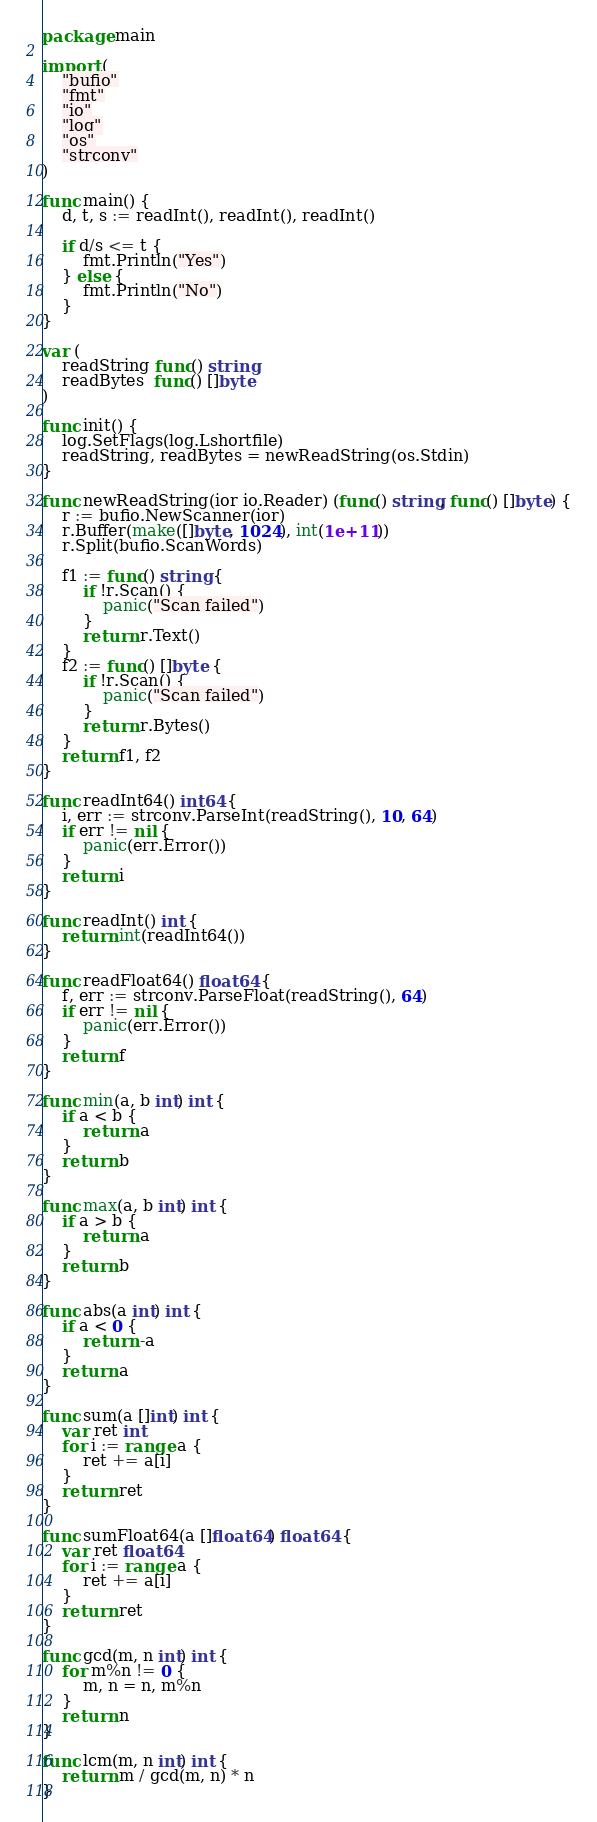Convert code to text. <code><loc_0><loc_0><loc_500><loc_500><_Go_>package main

import (
	"bufio"
	"fmt"
	"io"
	"log"
	"os"
	"strconv"
)

func main() {
	d, t, s := readInt(), readInt(), readInt()

	if d/s <= t {
		fmt.Println("Yes")
	} else {
		fmt.Println("No")
	}
}

var (
	readString func() string
	readBytes  func() []byte
)

func init() {
	log.SetFlags(log.Lshortfile)
	readString, readBytes = newReadString(os.Stdin)
}

func newReadString(ior io.Reader) (func() string, func() []byte) {
	r := bufio.NewScanner(ior)
	r.Buffer(make([]byte, 1024), int(1e+11))
	r.Split(bufio.ScanWords)

	f1 := func() string {
		if !r.Scan() {
			panic("Scan failed")
		}
		return r.Text()
	}
	f2 := func() []byte {
		if !r.Scan() {
			panic("Scan failed")
		}
		return r.Bytes()
	}
	return f1, f2
}

func readInt64() int64 {
	i, err := strconv.ParseInt(readString(), 10, 64)
	if err != nil {
		panic(err.Error())
	}
	return i
}

func readInt() int {
	return int(readInt64())
}

func readFloat64() float64 {
	f, err := strconv.ParseFloat(readString(), 64)
	if err != nil {
		panic(err.Error())
	}
	return f
}

func min(a, b int) int {
	if a < b {
		return a
	}
	return b
}

func max(a, b int) int {
	if a > b {
		return a
	}
	return b
}

func abs(a int) int {
	if a < 0 {
		return -a
	}
	return a
}

func sum(a []int) int {
	var ret int
	for i := range a {
		ret += a[i]
	}
	return ret
}

func sumFloat64(a []float64) float64 {
	var ret float64
	for i := range a {
		ret += a[i]
	}
	return ret
}

func gcd(m, n int) int {
	for m%n != 0 {
		m, n = n, m%n
	}
	return n
}

func lcm(m, n int) int {
	return m / gcd(m, n) * n
}
</code> 